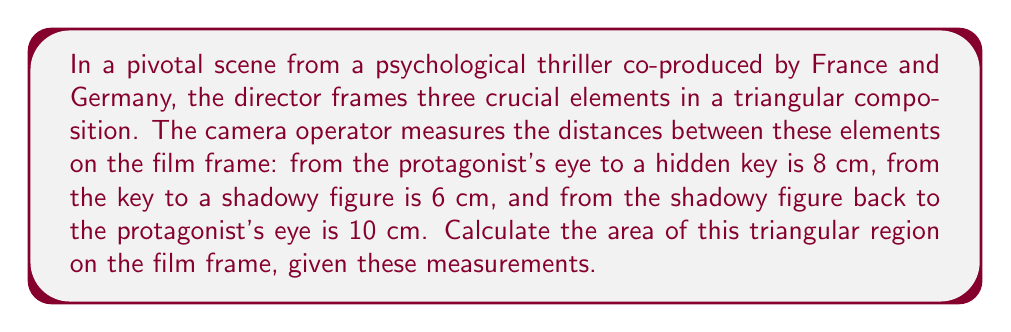What is the answer to this math problem? To solve this problem, we'll use Heron's formula for the area of a triangle given the lengths of its three sides. Let's approach this step-by-step:

1) Let's denote the sides of the triangle as:
   $a = 8$ cm (protagonist's eye to key)
   $b = 6$ cm (key to shadowy figure)
   $c = 10$ cm (shadowy figure to protagonist's eye)

2) Heron's formula states that the area $A$ of a triangle with sides $a$, $b$, and $c$ is:

   $$ A = \sqrt{s(s-a)(s-b)(s-c)} $$

   where $s$ is the semi-perimeter of the triangle:

   $$ s = \frac{a + b + c}{2} $$

3) Let's calculate $s$:

   $$ s = \frac{8 + 6 + 10}{2} = \frac{24}{2} = 12 $$

4) Now we can substitute all values into Heron's formula:

   $$ A = \sqrt{12(12-8)(12-6)(12-10)} $$

5) Simplify inside the parentheses:

   $$ A = \sqrt{12 \cdot 4 \cdot 6 \cdot 2} $$

6) Multiply the numbers inside the square root:

   $$ A = \sqrt{576} $$

7) Simplify the square root:

   $$ A = 24 $$

Therefore, the area of the triangular region on the film frame is 24 square centimeters.
Answer: $24$ cm² 